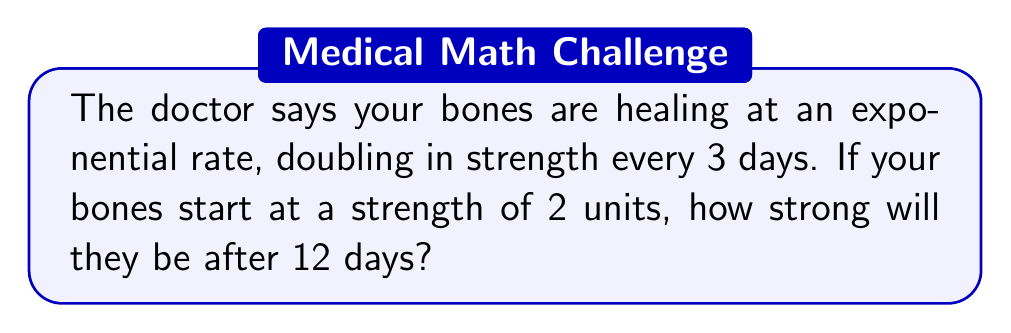Could you help me with this problem? Let's approach this step-by-step:

1) We start with an initial strength of 2 units.

2) The strength doubles every 3 days.

3) We need to find out how many times the strength doubles in 12 days:
   $12 \div 3 = 4$, so the strength doubles 4 times.

4) We can represent this mathematically as:
   $2 \times 2^4$

5) Let's calculate $2^4$:
   $2^4 = 2 \times 2 \times 2 \times 2 = 16$

6) Now, we multiply our initial strength by this:
   $2 \times 16 = 32$

Therefore, after 12 days, the bone strength will be 32 units.

Alternatively, we could have solved this using the exponential growth formula:
$$A = P(1+r)^t$$
Where:
A = final amount
P = initial amount (2)
r = growth rate (100% or 1, as it doubles)
t = number of growth periods (4)

$$A = 2(1+1)^4 = 2(2)^4 = 2(16) = 32$$
Answer: 32 units 